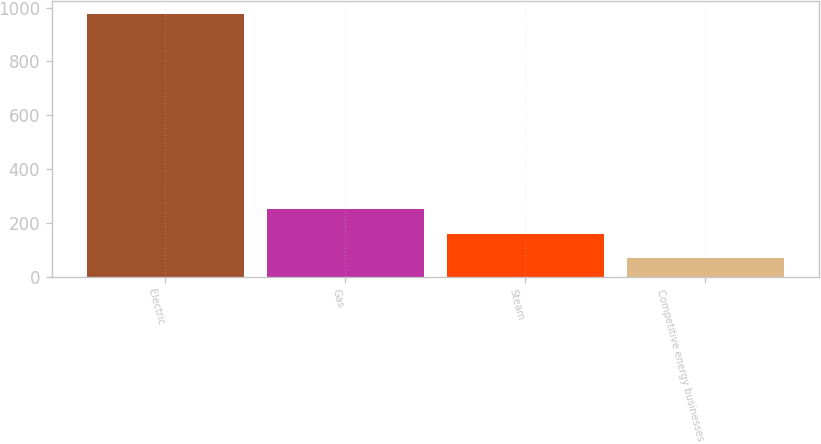Convert chart. <chart><loc_0><loc_0><loc_500><loc_500><bar_chart><fcel>Electric<fcel>Gas<fcel>Steam<fcel>Competitive energy businesses<nl><fcel>975<fcel>250.2<fcel>159.6<fcel>69<nl></chart> 